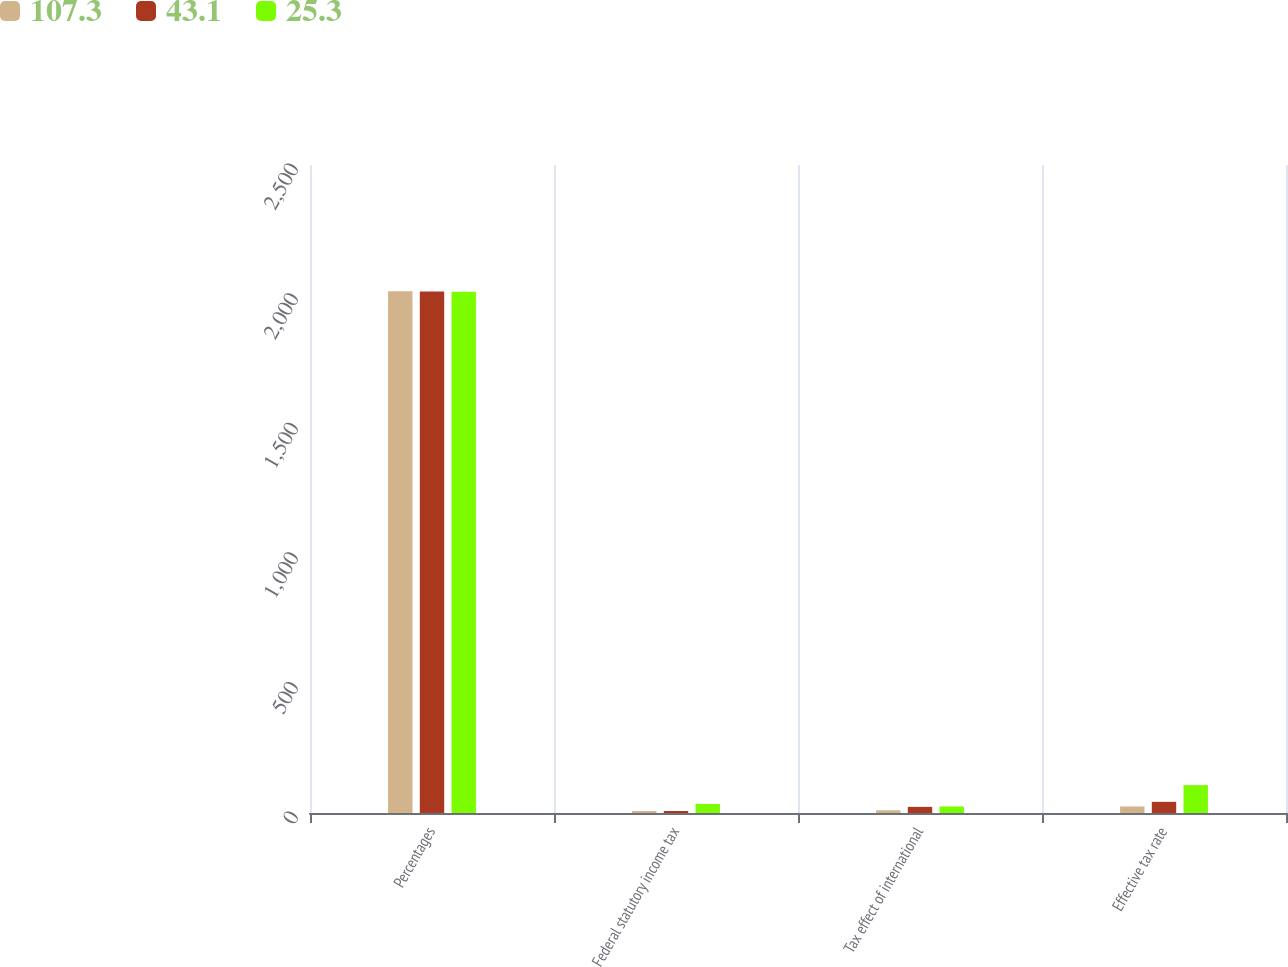Convert chart. <chart><loc_0><loc_0><loc_500><loc_500><stacked_bar_chart><ecel><fcel>Percentages<fcel>Federal statutory income tax<fcel>Tax effect of international<fcel>Effective tax rate<nl><fcel>107.3<fcel>2013<fcel>7.8<fcel>10.5<fcel>25.3<nl><fcel>43.1<fcel>2012<fcel>7.8<fcel>23.6<fcel>43.1<nl><fcel>25.3<fcel>2011<fcel>35<fcel>25.3<fcel>107.3<nl></chart> 